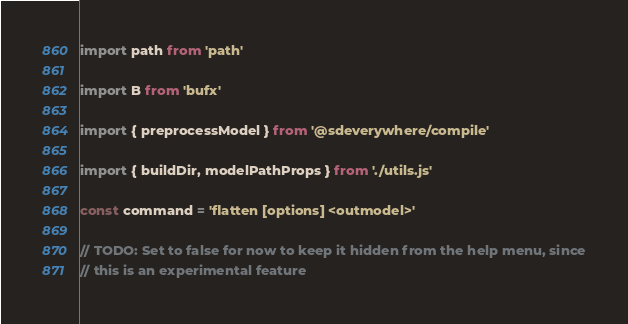Convert code to text. <code><loc_0><loc_0><loc_500><loc_500><_JavaScript_>import path from 'path'

import B from 'bufx'

import { preprocessModel } from '@sdeverywhere/compile'

import { buildDir, modelPathProps } from './utils.js'

const command = 'flatten [options] <outmodel>'

// TODO: Set to false for now to keep it hidden from the help menu, since
// this is an experimental feature</code> 